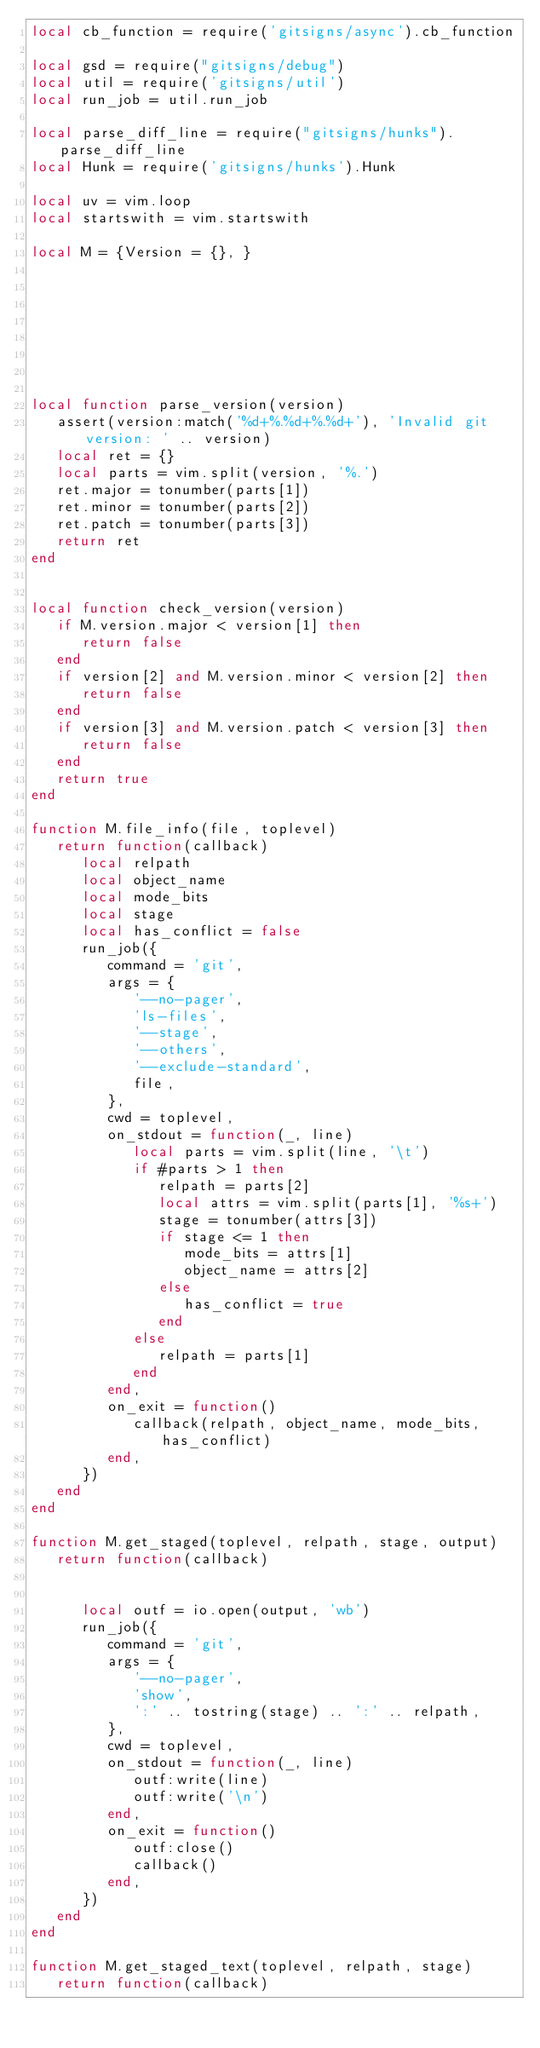Convert code to text. <code><loc_0><loc_0><loc_500><loc_500><_Lua_>local cb_function = require('gitsigns/async').cb_function

local gsd = require("gitsigns/debug")
local util = require('gitsigns/util')
local run_job = util.run_job

local parse_diff_line = require("gitsigns/hunks").parse_diff_line
local Hunk = require('gitsigns/hunks').Hunk

local uv = vim.loop
local startswith = vim.startswith

local M = {Version = {}, }








local function parse_version(version)
   assert(version:match('%d+%.%d+%.%d+'), 'Invalid git version: ' .. version)
   local ret = {}
   local parts = vim.split(version, '%.')
   ret.major = tonumber(parts[1])
   ret.minor = tonumber(parts[2])
   ret.patch = tonumber(parts[3])
   return ret
end


local function check_version(version)
   if M.version.major < version[1] then
      return false
   end
   if version[2] and M.version.minor < version[2] then
      return false
   end
   if version[3] and M.version.patch < version[3] then
      return false
   end
   return true
end

function M.file_info(file, toplevel)
   return function(callback)
      local relpath
      local object_name
      local mode_bits
      local stage
      local has_conflict = false
      run_job({
         command = 'git',
         args = {
            '--no-pager',
            'ls-files',
            '--stage',
            '--others',
            '--exclude-standard',
            file,
         },
         cwd = toplevel,
         on_stdout = function(_, line)
            local parts = vim.split(line, '\t')
            if #parts > 1 then
               relpath = parts[2]
               local attrs = vim.split(parts[1], '%s+')
               stage = tonumber(attrs[3])
               if stage <= 1 then
                  mode_bits = attrs[1]
                  object_name = attrs[2]
               else
                  has_conflict = true
               end
            else
               relpath = parts[1]
            end
         end,
         on_exit = function()
            callback(relpath, object_name, mode_bits, has_conflict)
         end,
      })
   end
end

function M.get_staged(toplevel, relpath, stage, output)
   return function(callback)


      local outf = io.open(output, 'wb')
      run_job({
         command = 'git',
         args = {
            '--no-pager',
            'show',
            ':' .. tostring(stage) .. ':' .. relpath,
         },
         cwd = toplevel,
         on_stdout = function(_, line)
            outf:write(line)
            outf:write('\n')
         end,
         on_exit = function()
            outf:close()
            callback()
         end,
      })
   end
end

function M.get_staged_text(toplevel, relpath, stage)
   return function(callback)</code> 